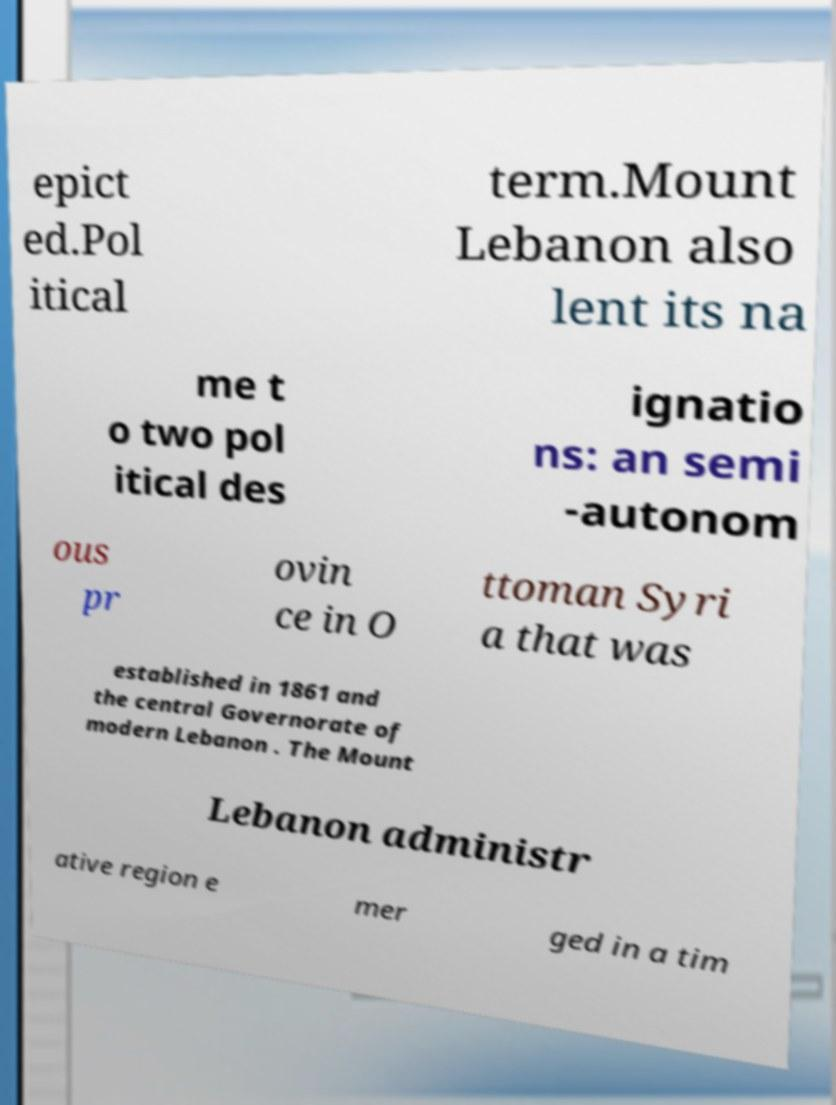I need the written content from this picture converted into text. Can you do that? epict ed.Pol itical term.Mount Lebanon also lent its na me t o two pol itical des ignatio ns: an semi -autonom ous pr ovin ce in O ttoman Syri a that was established in 1861 and the central Governorate of modern Lebanon . The Mount Lebanon administr ative region e mer ged in a tim 